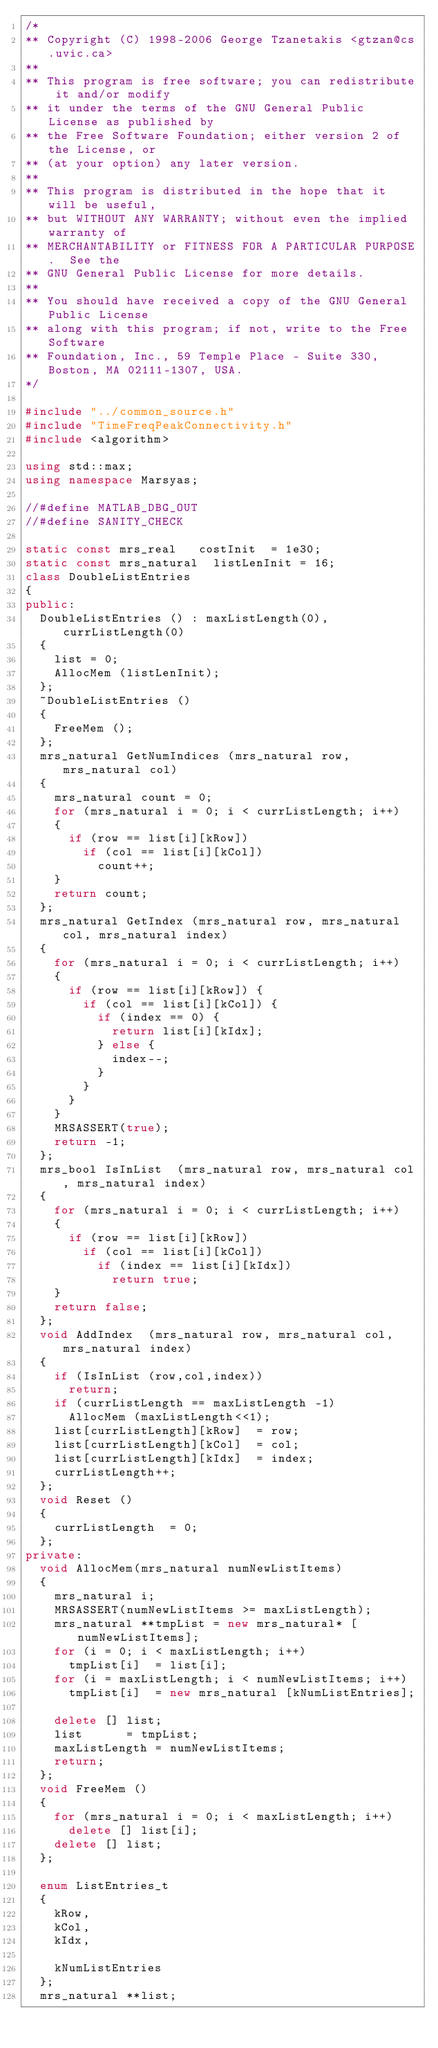<code> <loc_0><loc_0><loc_500><loc_500><_C++_>/*
** Copyright (C) 1998-2006 George Tzanetakis <gtzan@cs.uvic.ca>
**
** This program is free software; you can redistribute it and/or modify
** it under the terms of the GNU General Public License as published by
** the Free Software Foundation; either version 2 of the License, or
** (at your option) any later version.
**
** This program is distributed in the hope that it will be useful,
** but WITHOUT ANY WARRANTY; without even the implied warranty of
** MERCHANTABILITY or FITNESS FOR A PARTICULAR PURPOSE.  See the
** GNU General Public License for more details.
**
** You should have received a copy of the GNU General Public License
** along with this program; if not, write to the Free Software
** Foundation, Inc., 59 Temple Place - Suite 330, Boston, MA 02111-1307, USA.
*/

#include "../common_source.h"
#include "TimeFreqPeakConnectivity.h"
#include <algorithm>

using std::max;
using namespace Marsyas;

//#define MATLAB_DBG_OUT
//#define SANITY_CHECK

static const mrs_real		costInit	= 1e30;
static const mrs_natural	listLenInit = 16;
class DoubleListEntries
{
public:
  DoubleListEntries () : maxListLength(0),currListLength(0)
  {
    list = 0;
    AllocMem (listLenInit);
  };
  ~DoubleListEntries ()
  {
    FreeMem ();
  };
  mrs_natural GetNumIndices (mrs_natural row, mrs_natural col)
  {
    mrs_natural count = 0;
    for (mrs_natural i = 0; i < currListLength; i++)
    {
      if (row == list[i][kRow])
        if (col == list[i][kCol])
          count++;
    }
    return count;
  };
  mrs_natural GetIndex (mrs_natural row, mrs_natural col, mrs_natural index)
  {
    for (mrs_natural i = 0; i < currListLength; i++)
    {
      if (row == list[i][kRow]) {
        if (col == list[i][kCol]) {
          if (index == 0) {
            return list[i][kIdx];
          } else {
            index--;
          }
        }
      }
    }
    MRSASSERT(true);
    return -1;
  };
  mrs_bool IsInList  (mrs_natural row, mrs_natural col, mrs_natural index)
  {
    for (mrs_natural i = 0; i < currListLength; i++)
    {
      if (row == list[i][kRow])
        if (col == list[i][kCol])
          if (index == list[i][kIdx])
            return true;
    }
    return false;
  };
  void AddIndex  (mrs_natural row, mrs_natural col, mrs_natural index)
  {
    if (IsInList (row,col,index))
      return;
    if (currListLength == maxListLength -1)
      AllocMem (maxListLength<<1);
    list[currListLength][kRow]	= row;
    list[currListLength][kCol]	= col;
    list[currListLength][kIdx]	= index;
    currListLength++;
  };
  void Reset ()
  {
    currListLength	= 0;
  };
private:
  void AllocMem(mrs_natural numNewListItems)
  {
    mrs_natural i;
    MRSASSERT(numNewListItems >= maxListLength);
    mrs_natural **tmpList = new mrs_natural* [numNewListItems];
    for (i = 0; i < maxListLength; i++)
      tmpList[i]	= list[i];
    for (i = maxListLength; i < numNewListItems; i++)
      tmpList[i]	= new mrs_natural [kNumListEntries];

    delete [] list;
    list			= tmpList;
    maxListLength	= numNewListItems;
    return;
  };
  void FreeMem ()
  {
    for (mrs_natural i = 0; i < maxListLength; i++)
      delete [] list[i];
    delete [] list;
  };

  enum ListEntries_t
  {
    kRow,
    kCol,
    kIdx,

    kNumListEntries
  };
  mrs_natural **list;</code> 